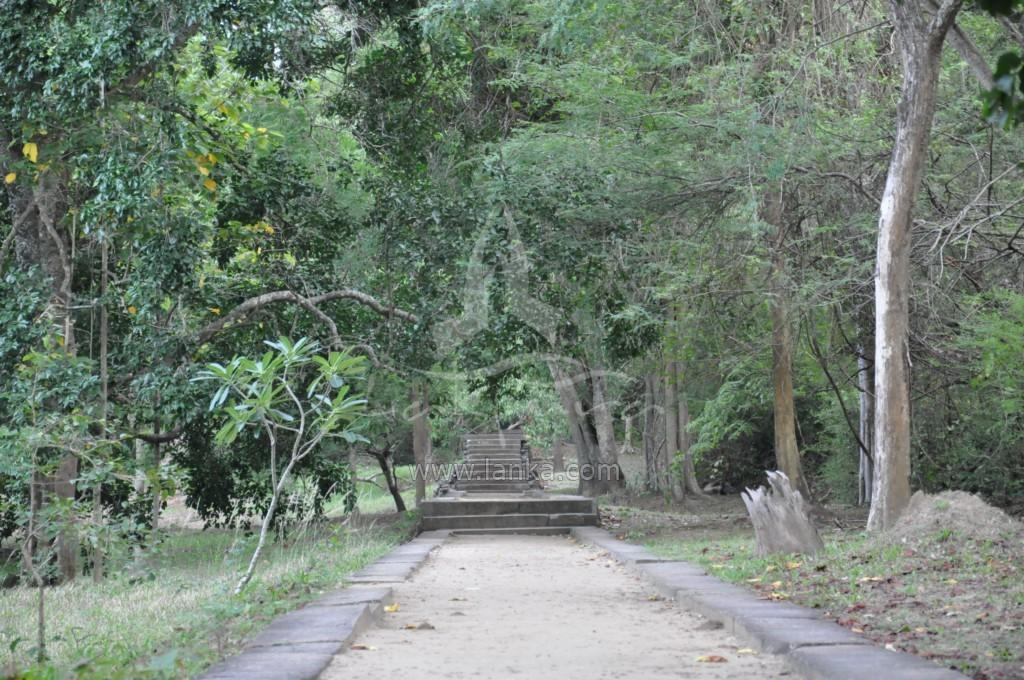What can be seen in the foreground of the picture? In the foreground of the picture, there are dry leaves, a path, a plant, soil, and grass. What is located in the center of the picture? In the center of the picture, there are trees, staircases, and grass. What grade is the library building in the image? There is no library building present in the image. How many carts are visible in the image? There are no carts visible in the image. 